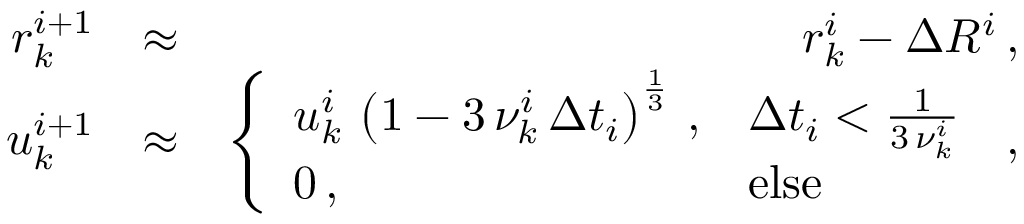<formula> <loc_0><loc_0><loc_500><loc_500>\begin{array} { r l r } { r _ { k } ^ { i + 1 } } & { \approx } & { r _ { k } ^ { i } - \Delta R ^ { i } \, , } \\ { u _ { k } ^ { i + 1 } } & { \approx } & { \left \{ \begin{array} { l l } { u _ { k } ^ { i } \, \left ( 1 - 3 \, \nu _ { k } ^ { i } \, \Delta t _ { i } \right ) ^ { \frac { 1 } { 3 } } \, , } & { \Delta t _ { i } < \frac { 1 } { 3 \, \nu _ { k } ^ { i } } } \\ { 0 \, , } & { e l s e } \end{array} \, , } \end{array}</formula> 